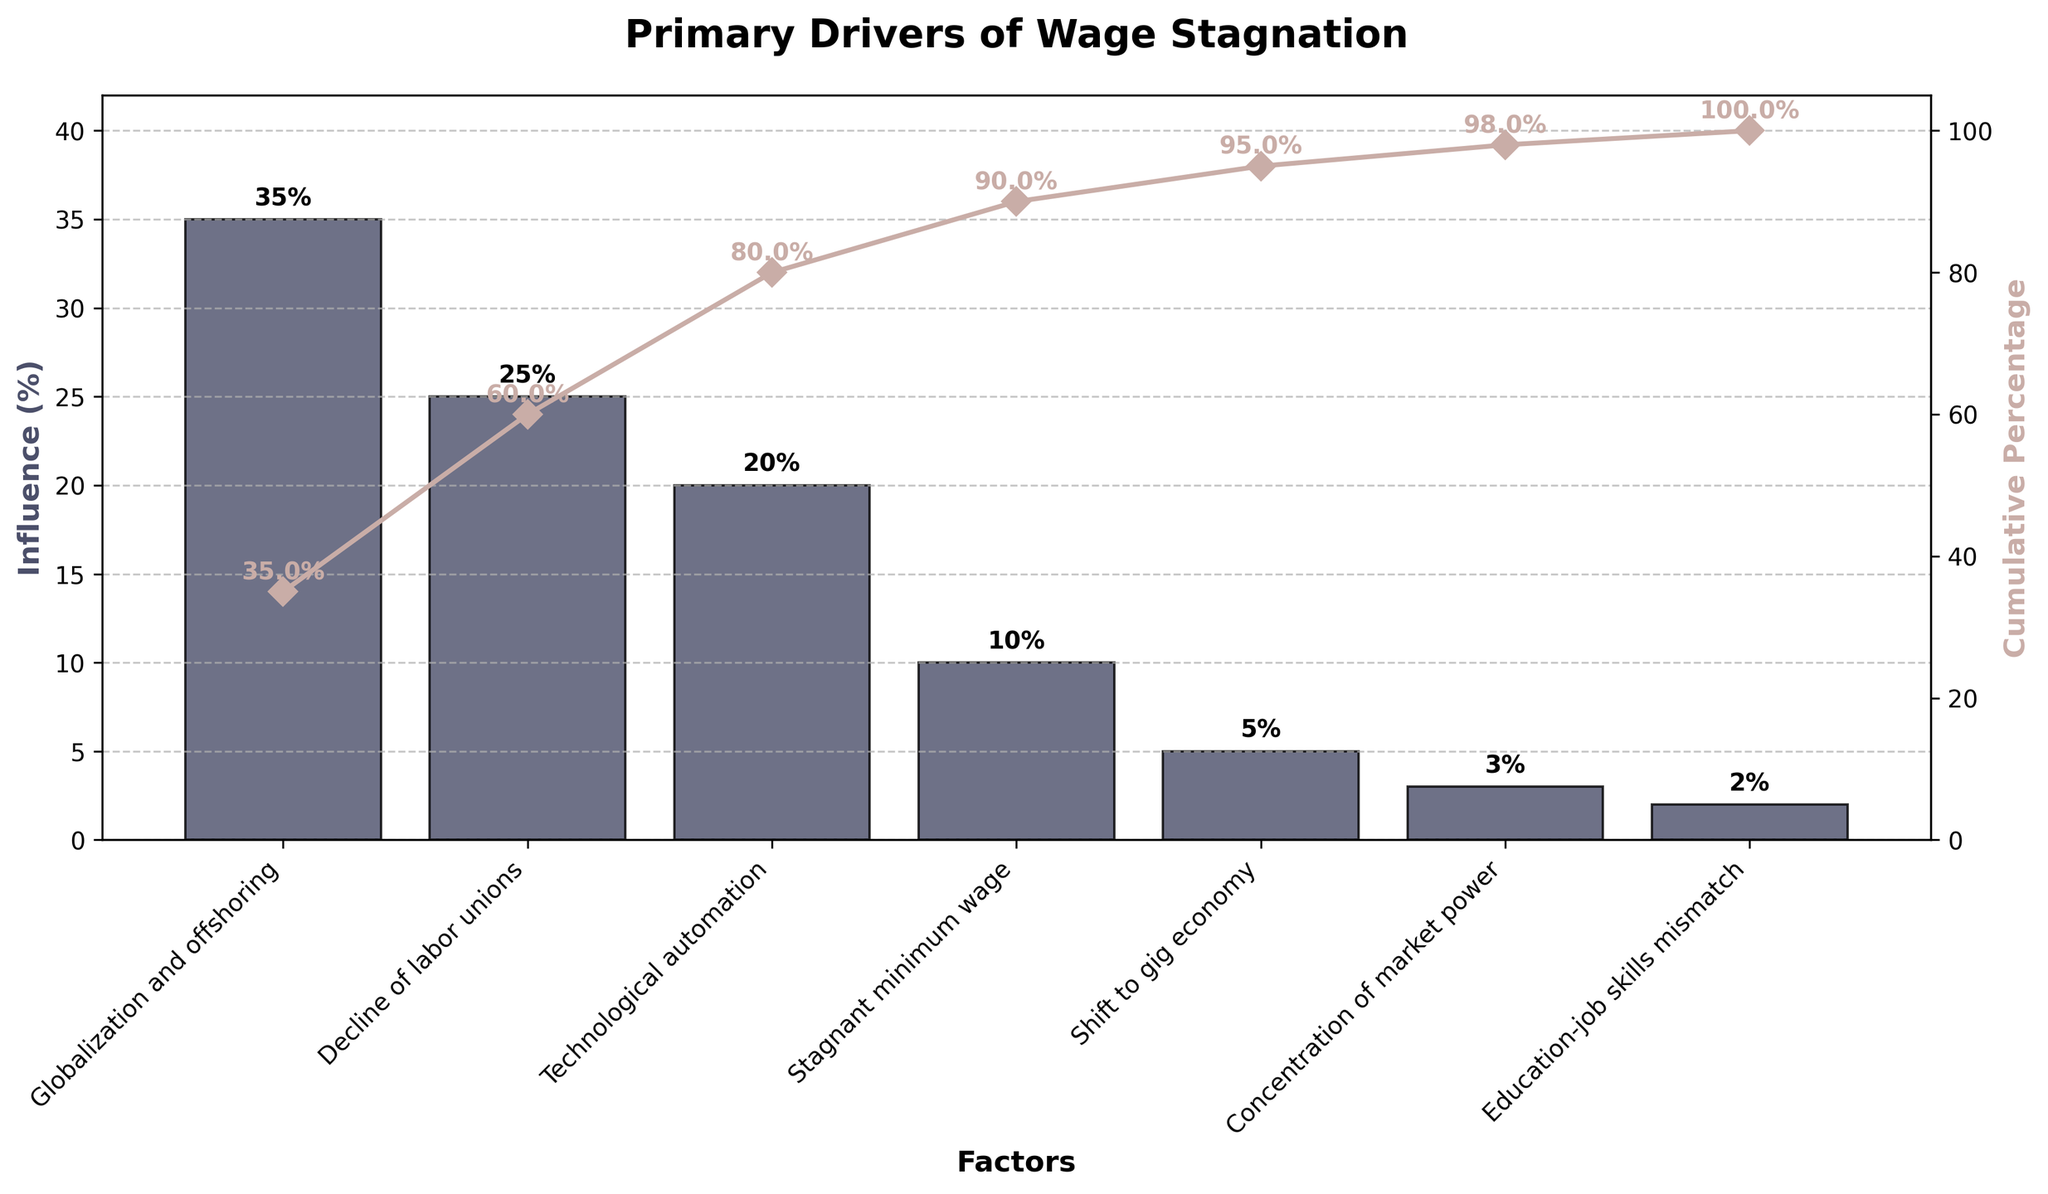What is the title of the chart? The title is located at the top of the chart, and it states the subject of the chart. In this case, the title reads "Primary Drivers of Wage Stagnation".
Answer: Primary Drivers of Wage Stagnation Which factor has the highest influence on wage stagnation? The influence is shown by the height of the bars, and the tallest bar represents the factor with the highest influence. Here, "Globalization and offshoring" has the highest bar.
Answer: Globalization and offshoring What is the cumulative percentage of the influence up to the decline of labor unions? From the cumulative percentage line, the value at the point corresponding to "Decline of labor unions" is listed as 60%.
Answer: 60% How many factors contribute to wage stagnation according to the chart? The number of factors is equal to the number of distinct labels on the x-axis. In this case, there are seven factors listed.
Answer: Seven By how much does the influence of globalization and offshoring exceed that of stagnation minimum wage? Globalization and offshoring influence is 35%, and stagnant minimum wage is 10%. The difference is calculated as 35% - 10%.
Answer: 25% Which two factors together contribute the most to wage stagnation in terms of influence percentage? By looking at the individual influence percentages, the two highest are "Globalization and offshoring" (35%) and "Decline of labor unions" (25%). Together, they contribute 35% + 25%.
Answer: Globalization and offshoring and decline of labor unions What is the total influence percentage of shift to gig economy, concentration of market power, and education-job skills mismatch combined? Sum their individual influences: 5% + 3% + 2%. The combined total is 5 + 3 + 2.
Answer: 10% Which factor marks the point at which the cumulative percentage reaches over 90%? Observe the cumulative percentage line; "Shift to gig economy" crosses the cumulative percentage over 90%.
Answer: Shift to gig economy Rank the factors in order from highest to lowest influence. The factors can be ordered by the height of their bars. From highest to lowest: 
1. Globalization and offshoring 
2. Decline of labor unions 
3. Technological automation 
4. Stagnant minimum wage 
5. Shift to gig economy 
6. Concentration of market power 
7. Education-job skills mismatch.
Answer: Globalization and offshoring, Decline of labor unions, Technological automation, Stagnant minimum wage, Shift to gig economy, Concentration of market power, Education-job skills mismatch 